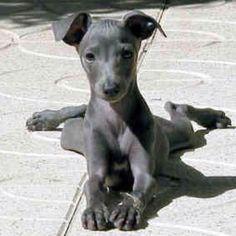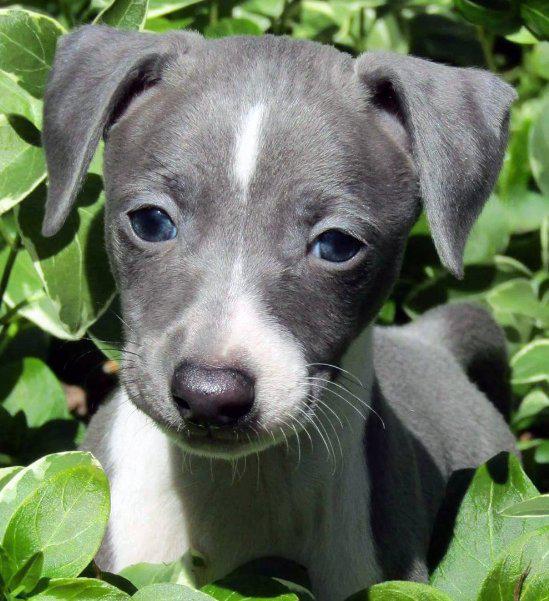The first image is the image on the left, the second image is the image on the right. For the images displayed, is the sentence "There is a fence behind a dog." factually correct? Answer yes or no. No. The first image is the image on the left, the second image is the image on the right. Assess this claim about the two images: "In 1 of the images, 1 dog is facing forward indoors.". Correct or not? Answer yes or no. No. 